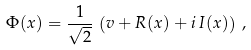<formula> <loc_0><loc_0><loc_500><loc_500>\Phi ( x ) = \frac { 1 } { \sqrt { 2 } } \, \left ( v + R ( x ) + i \, I ( x ) \right ) \, ,</formula> 